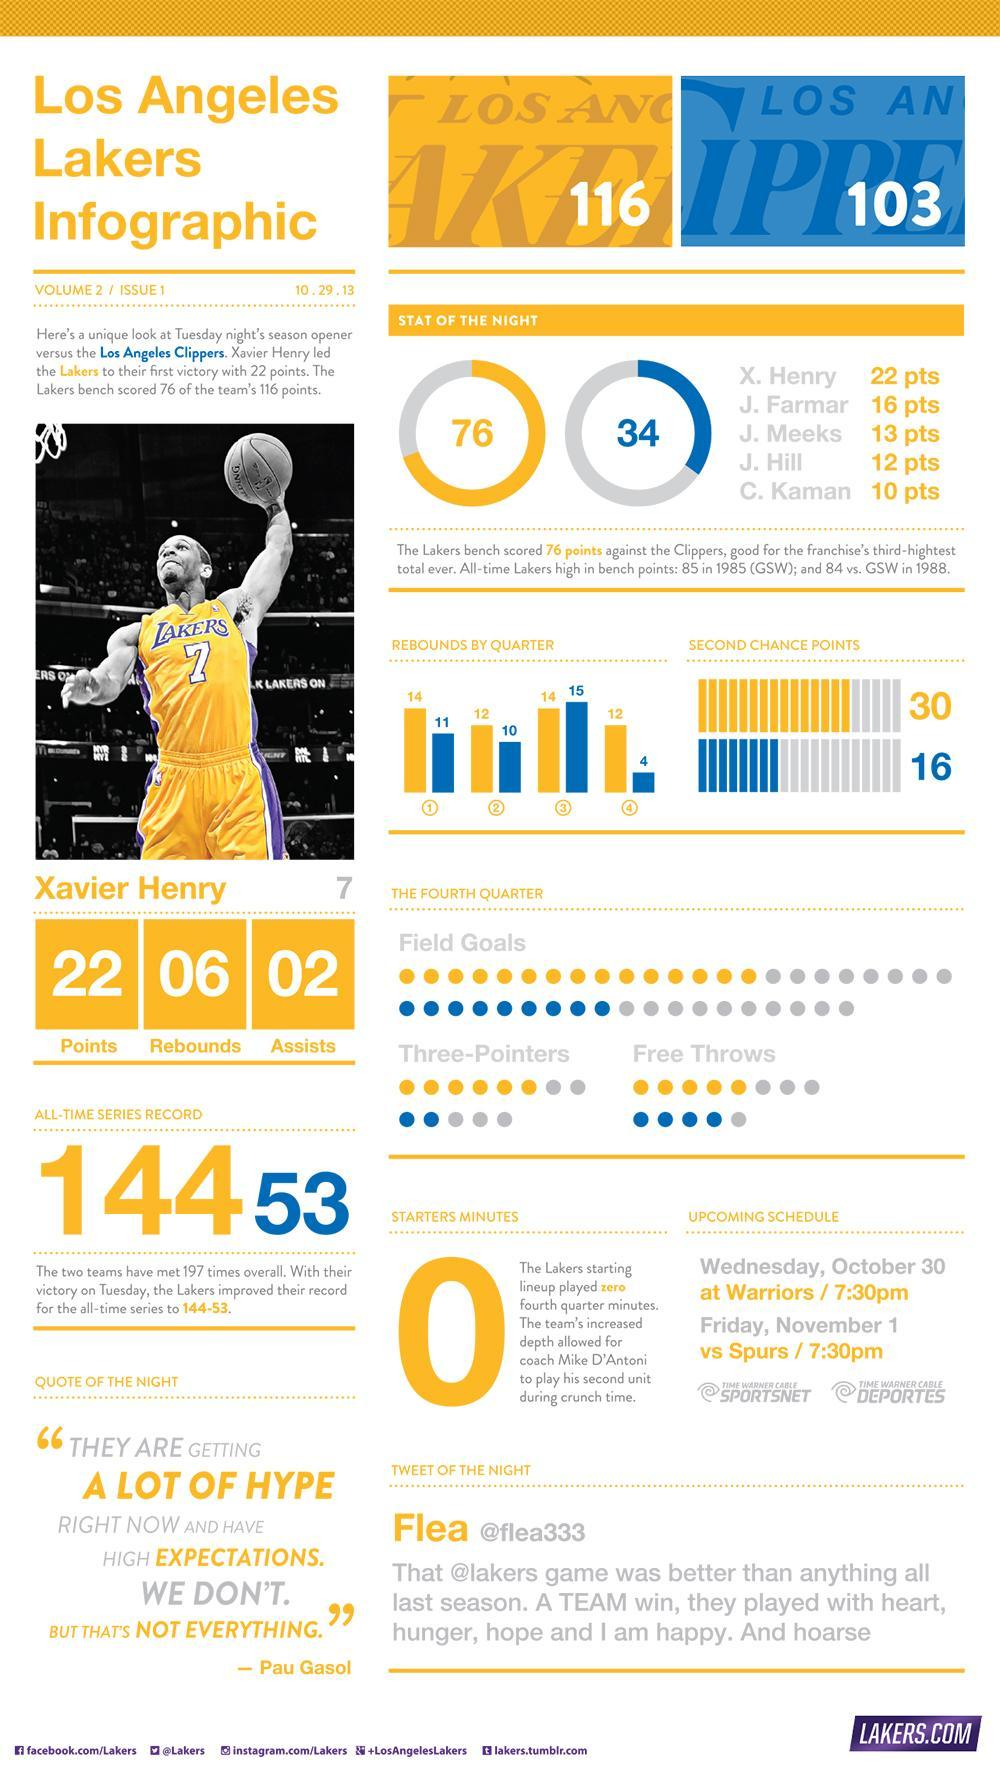How many second chance points did the Lakers score?
Answer the question with a short phrase. 30 How many players in the Lakers team scored higher than 10 points? 4 How many rebounds did the Clippers have in the third quarter? 15 How many total points did the Los Angeles Clippers get? 103 Which team had 10 rebounds in the second quarter? Clippers Which team had 14 rebounds in the first quarter? Lakers How many free throws did the Lakers make in the fourth quarter? 5 How many second chance points did the Clippers score? 16 How many points did the Clippers score in the season opener match against the Lakers? 34 How many rebounds did the Lakers have in the second quarter? 12 